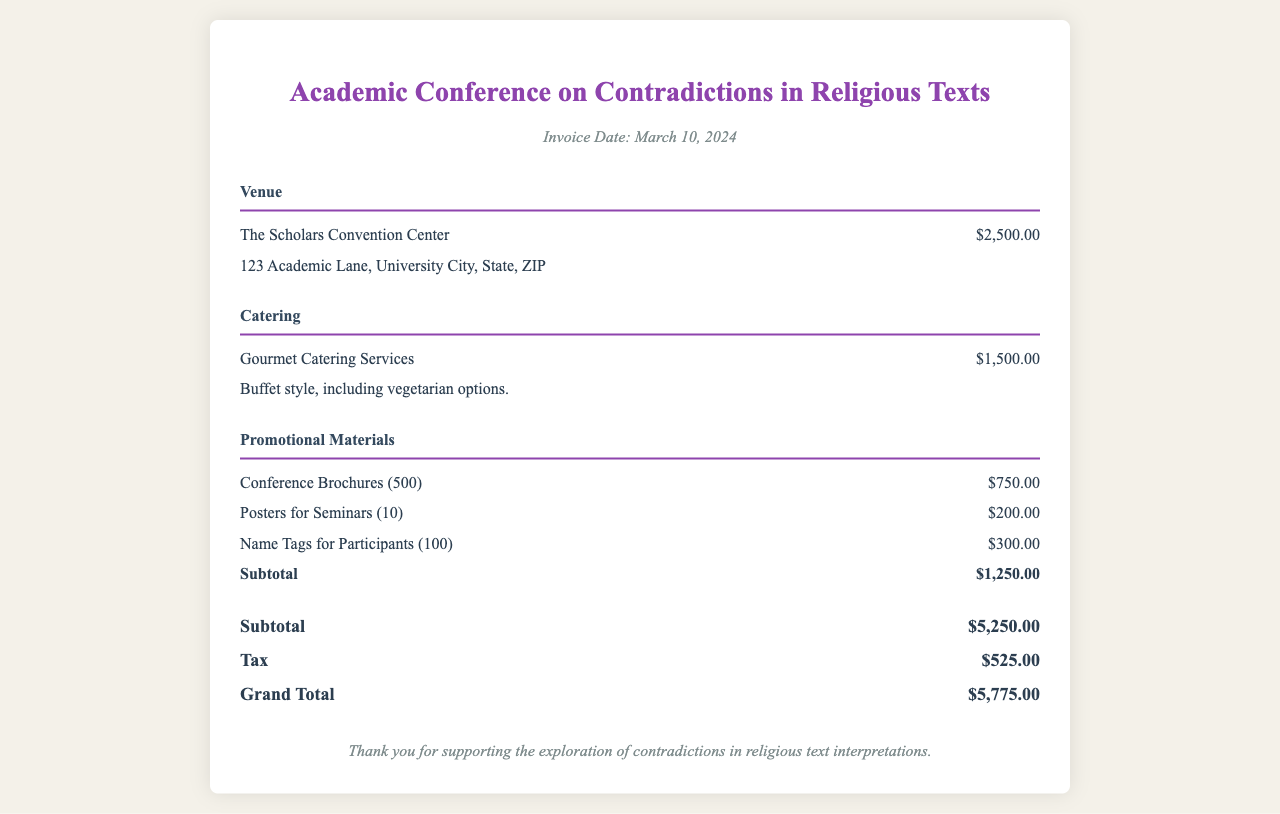What is the invoice date? The invoice date is mentioned in the header section of the document.
Answer: March 10, 2024 What is the venue cost? The venue cost is specified under the Venue section of the document.
Answer: $2,500.00 What is included in the catering service? The catering service information includes details about the catering style and options.
Answer: Buffet style, including vegetarian options What is the total amount for promotional materials? The total for promotional materials is provided at the end of the Promotional Materials section.
Answer: $1,250.00 What is the grand total? The grand total is calculated by adding the subtotal and tax in the Total section.
Answer: $5,775.00 Which catering service is mentioned? The name of the catering service can be found in the Catering section of the document.
Answer: Gourmet Catering Services What is the subtotal before tax? The subtotal is the sum of all the costs listed before tax in the Total section.
Answer: $5,250.00 What type of event is this invoice for? The type of event is indicated in the title of the document.
Answer: Academic Conference on Contradictions in Religious Texts 